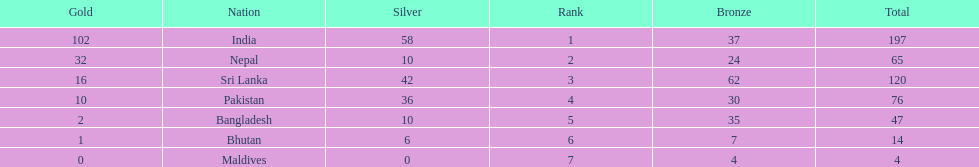How many more gold medals has nepal won than pakistan? 22. 